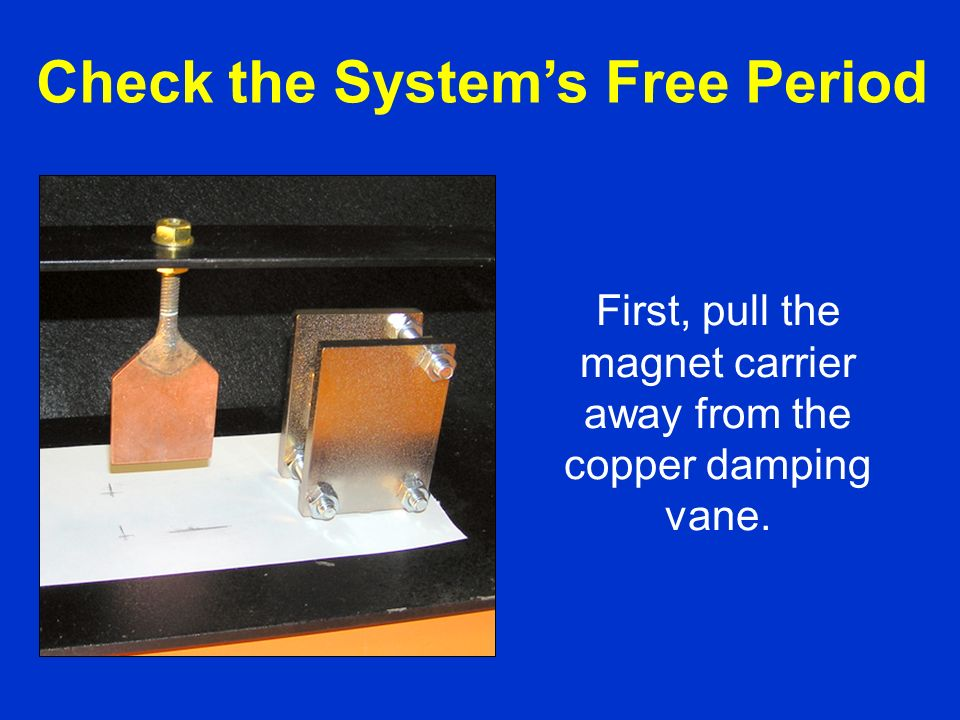Can you explain why the copper damping vane is essential in this setup? The copper damping vane is essential in this setup because it helps visualize the principle of magnetic damping. When the magnet is moved, it induces eddy currents in the copper vane. These eddy currents generate a magnetic field that opposes the motion of the magnet, effectively slowing it down. This opposition is a manifestation of Lenz's Law, which states that the induced electromotive force always opposes the change in magnetic flux that caused it. Without the copper vane, this effect wouldn't be observable in the sharegpt4v/same way, demonstrating the practical application of theoretical principles. 